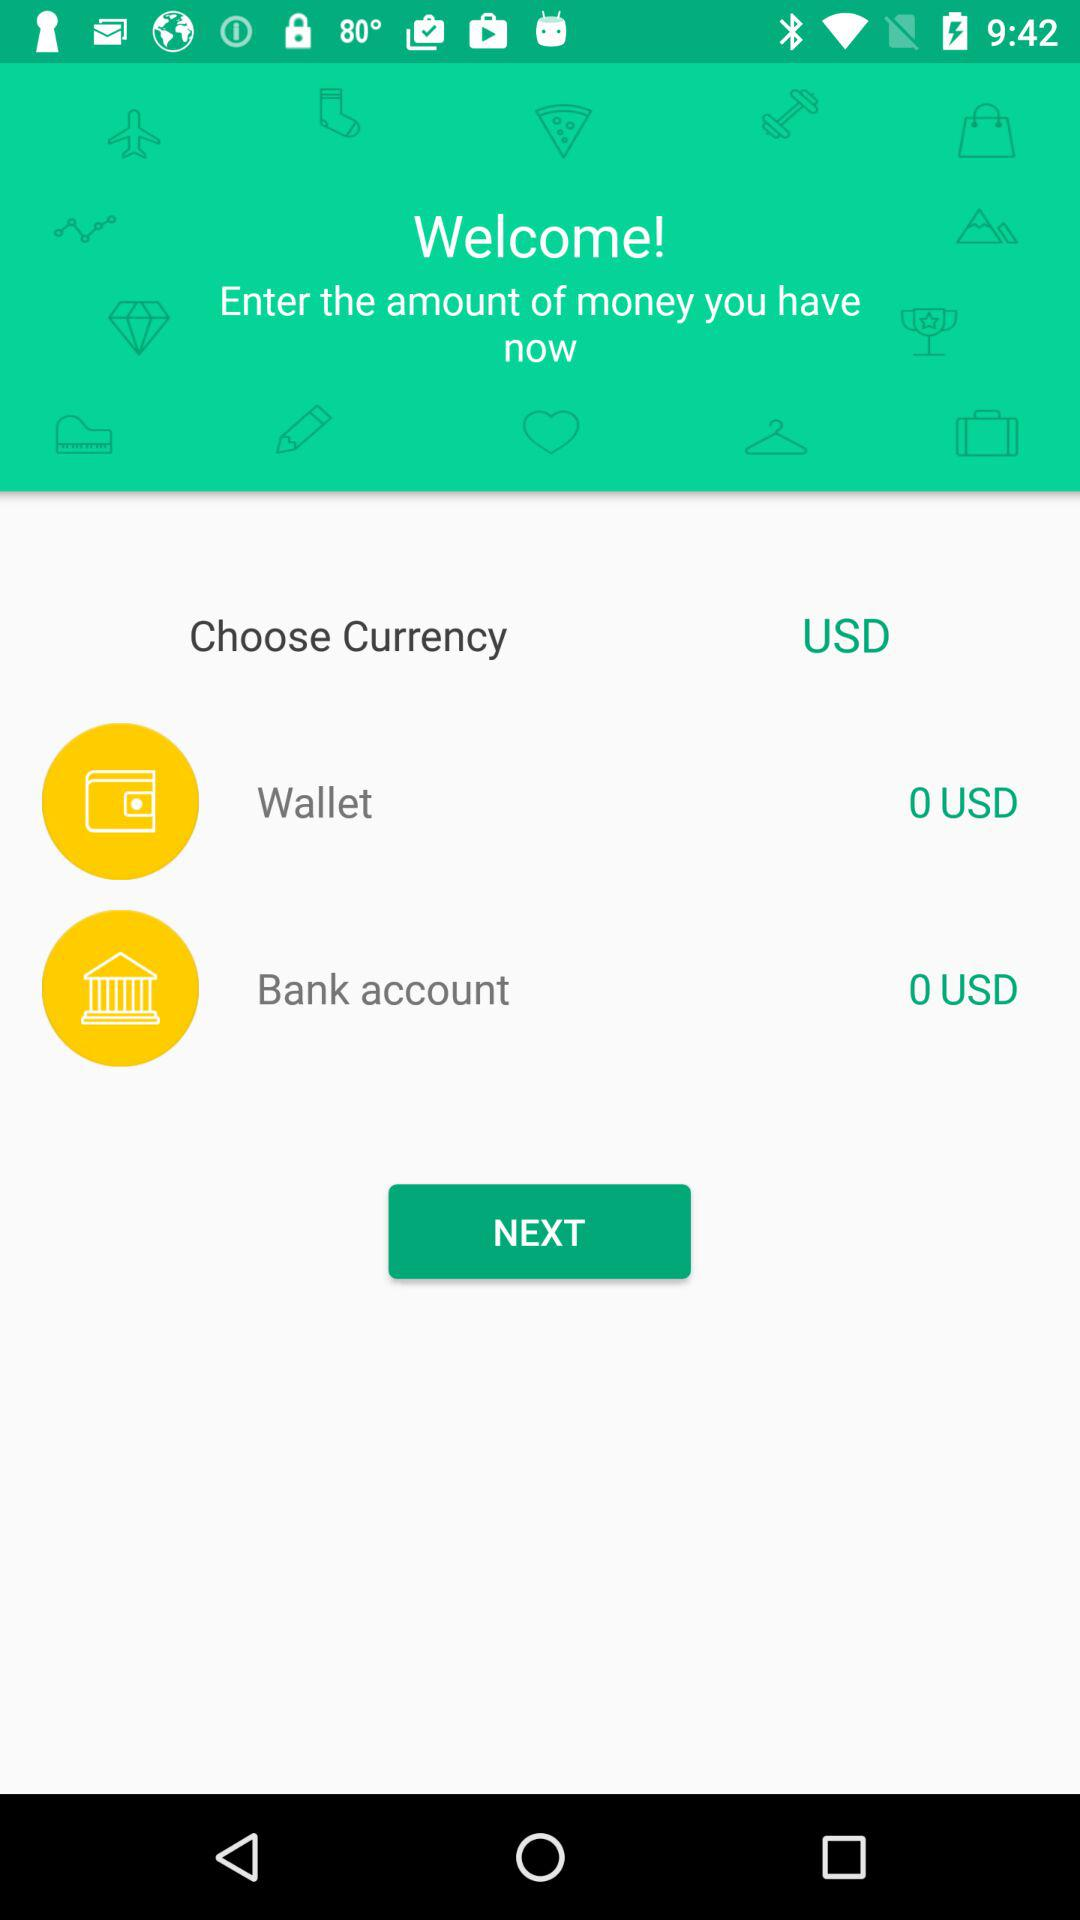Which currency is selected? The selected currency is USD. 